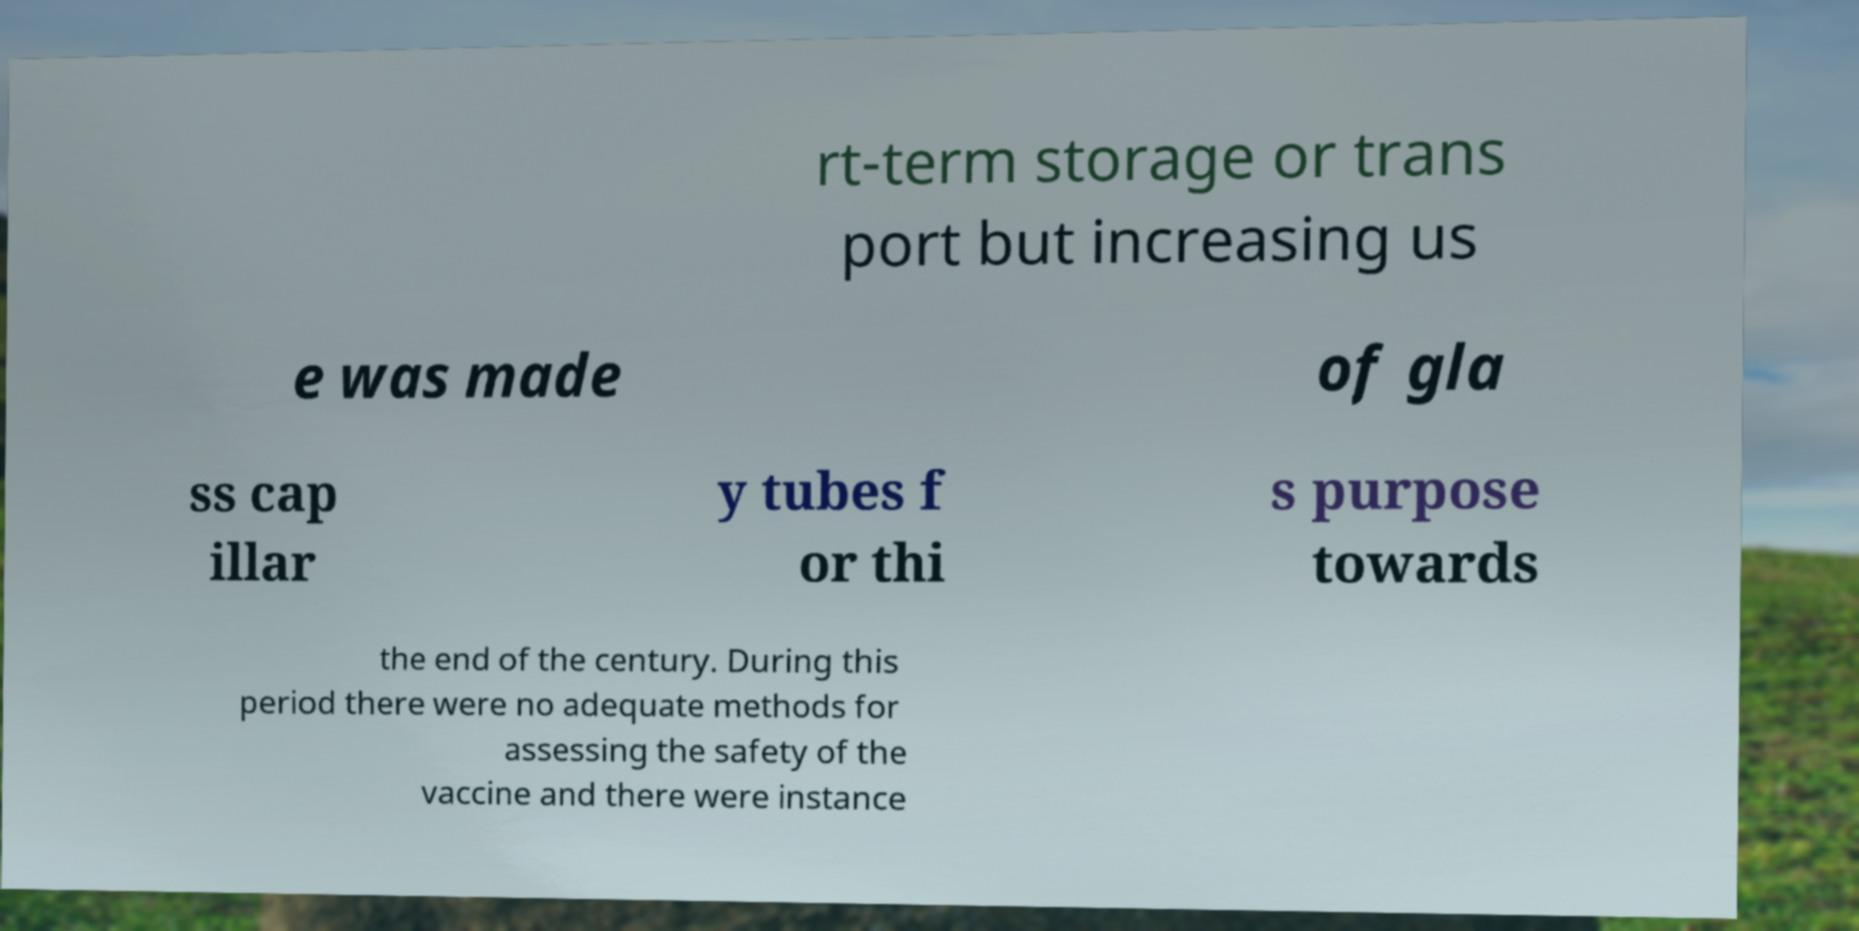Could you assist in decoding the text presented in this image and type it out clearly? rt-term storage or trans port but increasing us e was made of gla ss cap illar y tubes f or thi s purpose towards the end of the century. During this period there were no adequate methods for assessing the safety of the vaccine and there were instance 